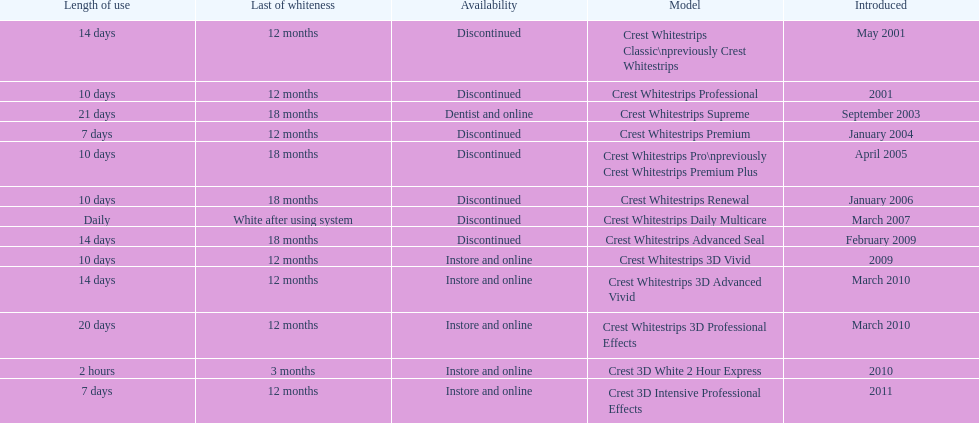How many products have been discontinued? 7. 